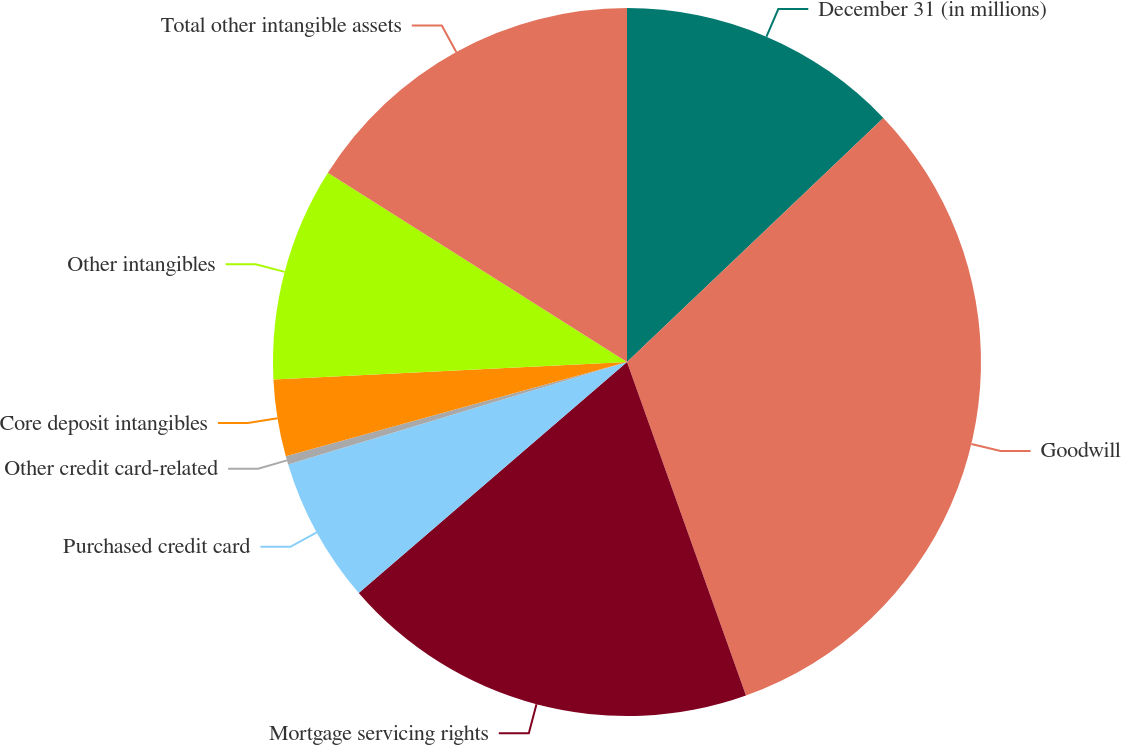Convert chart to OTSL. <chart><loc_0><loc_0><loc_500><loc_500><pie_chart><fcel>December 31 (in millions)<fcel>Goodwill<fcel>Mortgage servicing rights<fcel>Purchased credit card<fcel>Other credit card-related<fcel>Core deposit intangibles<fcel>Other intangibles<fcel>Total other intangible assets<nl><fcel>12.89%<fcel>31.65%<fcel>19.14%<fcel>6.64%<fcel>0.38%<fcel>3.51%<fcel>9.76%<fcel>16.02%<nl></chart> 